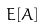Convert formula to latex. <formula><loc_0><loc_0><loc_500><loc_500>E [ A ]</formula> 